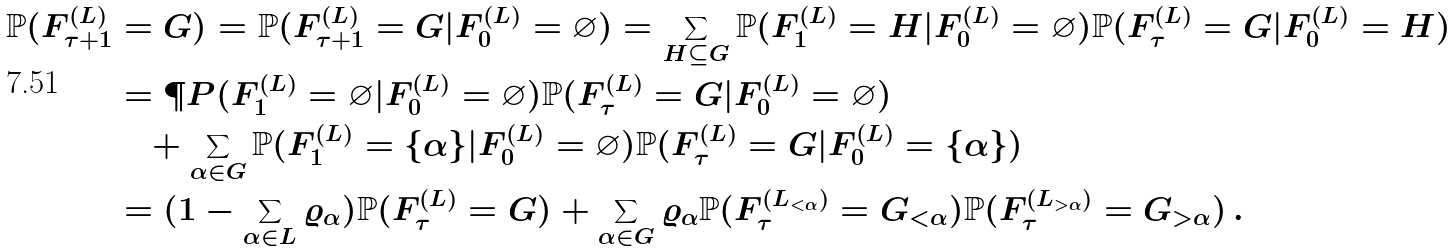<formula> <loc_0><loc_0><loc_500><loc_500>\mathbb { P } ( F ^ { ( L ) } _ { \tau + 1 } & = G ) = \mathbb { P } ( F ^ { ( L ) } _ { \tau + 1 } = G | F ^ { ( L ) } _ { 0 } = \varnothing ) = \sum _ { H \subseteq G } \mathbb { P } ( F ^ { ( L ) } _ { 1 } = H | F ^ { ( L ) } _ { 0 } = \varnothing ) \mathbb { P } ( F ^ { ( L ) } _ { \tau } = G | F ^ { ( L ) } _ { 0 } = H ) \\ & = \P P ( F _ { 1 } ^ { ( L ) } = \varnothing | F _ { 0 } ^ { ( L ) } = \varnothing ) \mathbb { P } ( F ^ { ( L ) } _ { \tau } = G | F ^ { ( L ) } _ { 0 } = \varnothing ) \\ & \quad + \sum _ { \alpha \in G } \mathbb { P } ( F ^ { ( L ) } _ { 1 } = \{ \alpha \} | F ^ { ( L ) } _ { 0 } = \varnothing ) \mathbb { P } ( F ^ { ( L ) } _ { \tau } = G | F ^ { ( L ) } _ { 0 } = \{ \alpha \} ) \\ & = ( 1 - \sum _ { \alpha \in L } \varrho _ { \alpha } ) \mathbb { P } ( F ^ { ( L ) } _ { \tau } = G ) + \sum _ { \alpha \in G } \varrho _ { \alpha } \mathbb { P } ( F _ { \tau } ^ { ( L _ { < \alpha } ) } = G _ { < \alpha } ) \mathbb { P } ( F _ { \tau } ^ { ( L _ { > \alpha } ) } = G _ { > \alpha } ) \, .</formula> 